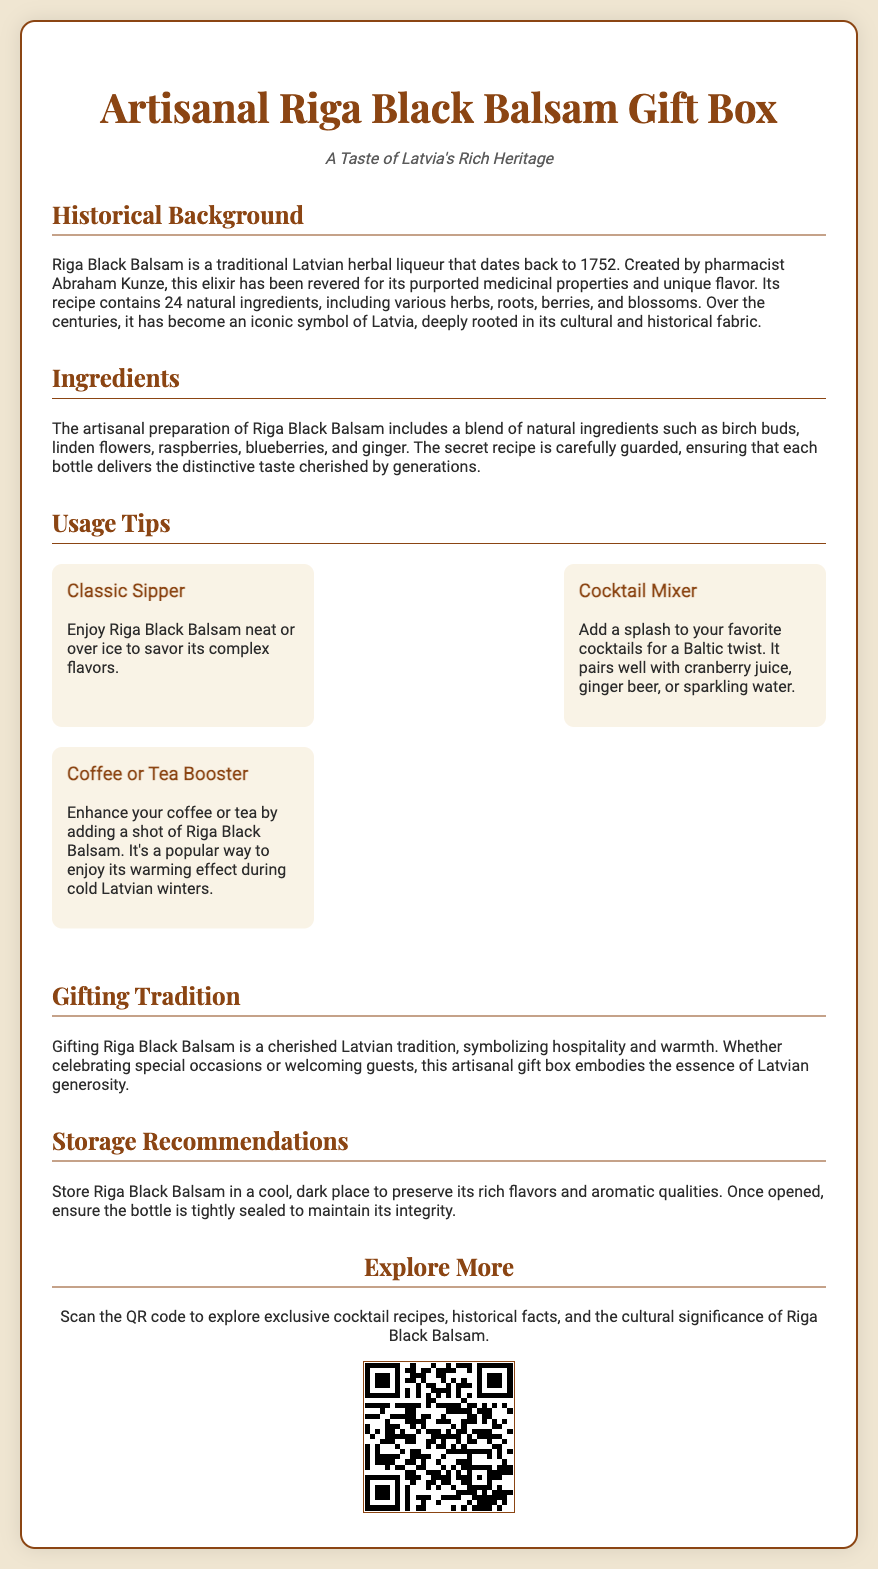What year was Riga Black Balsam created? The document states that Riga Black Balsam dates back to 1752.
Answer: 1752 Who created Riga Black Balsam? According to the historical background, Riga Black Balsam was created by pharmacist Abraham Kunze.
Answer: Abraham Kunze How many natural ingredients are in the recipe? The document mentions that the recipe contains 24 natural ingredients.
Answer: 24 What should you add to coffee or tea according to the usage tips? The document advises adding a shot of Riga Black Balsam to enhance coffee or tea.
Answer: Riga Black Balsam What is a recommended way to enjoy Riga Black Balsam? The document suggests enjoying it neat or over ice to savor its complex flavors.
Answer: Neat or over ice What does gifting Riga Black Balsam symbolize? The document states that gifting Riga Black Balsam symbolizes hospitality and warmth.
Answer: Hospitality and warmth What is one type of drink to mix with Riga Black Balsam? The usage tips include mixing Riga Black Balsam with cranberry juice.
Answer: Cranberry juice How should Riga Black Balsam be stored? The document recommends storing it in a cool, dark place.
Answer: Cool, dark place 